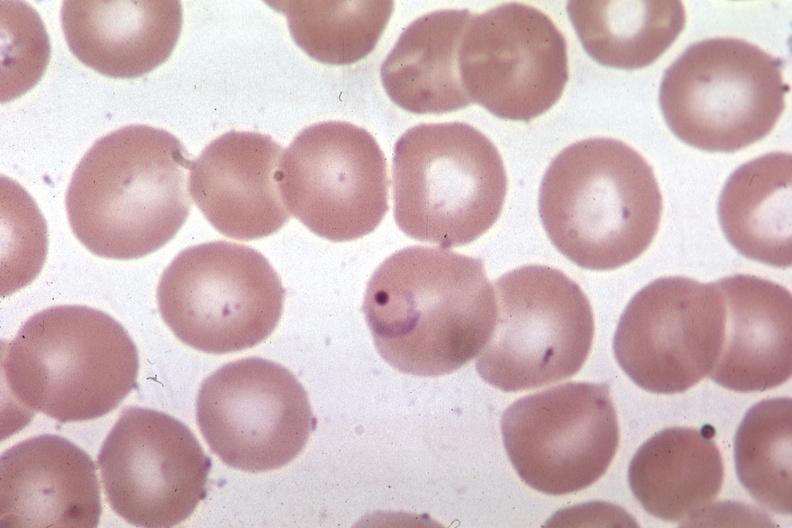s wonder present?
Answer the question using a single word or phrase. No 